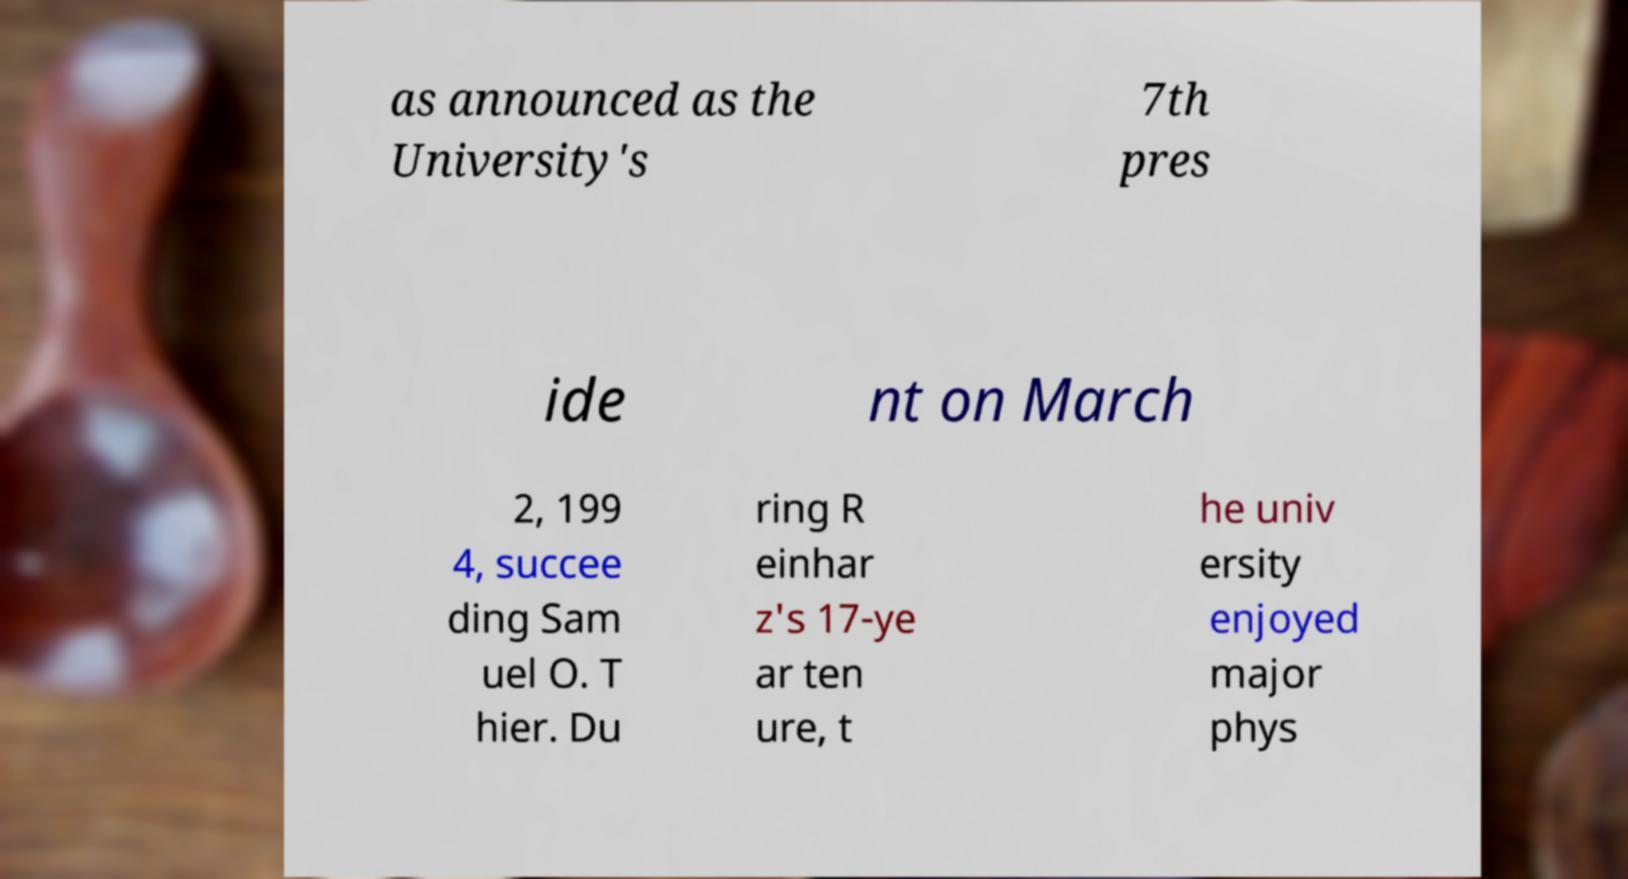Can you accurately transcribe the text from the provided image for me? as announced as the University's 7th pres ide nt on March 2, 199 4, succee ding Sam uel O. T hier. Du ring R einhar z's 17-ye ar ten ure, t he univ ersity enjoyed major phys 